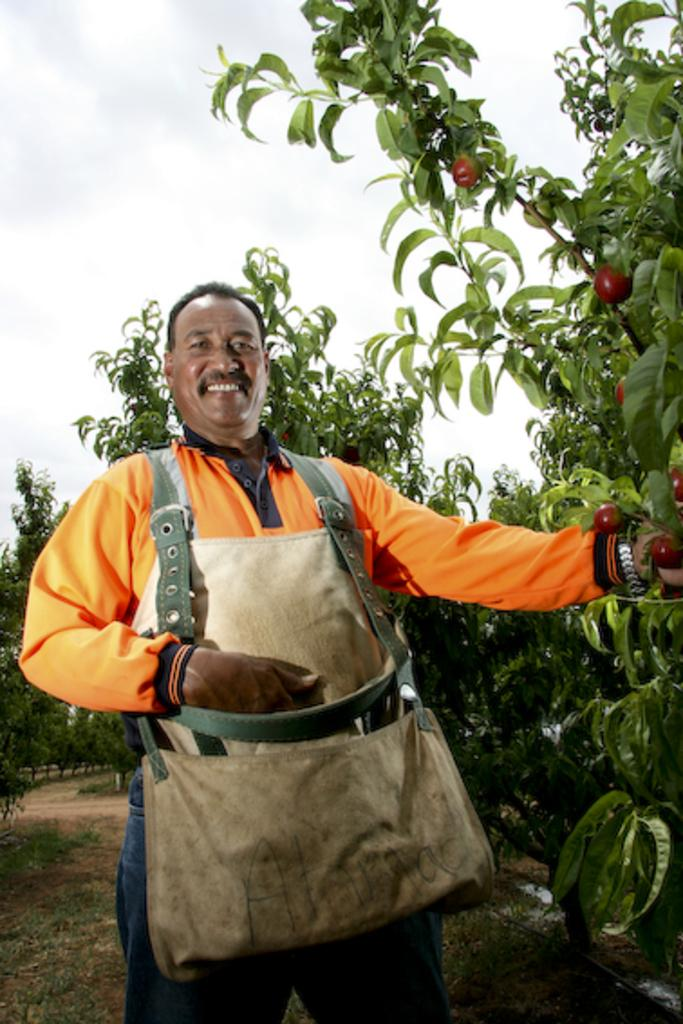Who is present in the image? There is a man in the image. What is the man's facial expression? The man is smiling. What type of natural environment can be seen in the image? There are trees in the image. What type of food items are visible in the image? There are fruits in the image. What object might be used for carrying items in the image? There is a bag in the image. How much debt does the man owe in the image? There is no information about the man's debt in the image. What type of cattle can be seen grazing in the image? There are no cattle present in the image. 